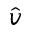<formula> <loc_0><loc_0><loc_500><loc_500>\hat { v }</formula> 